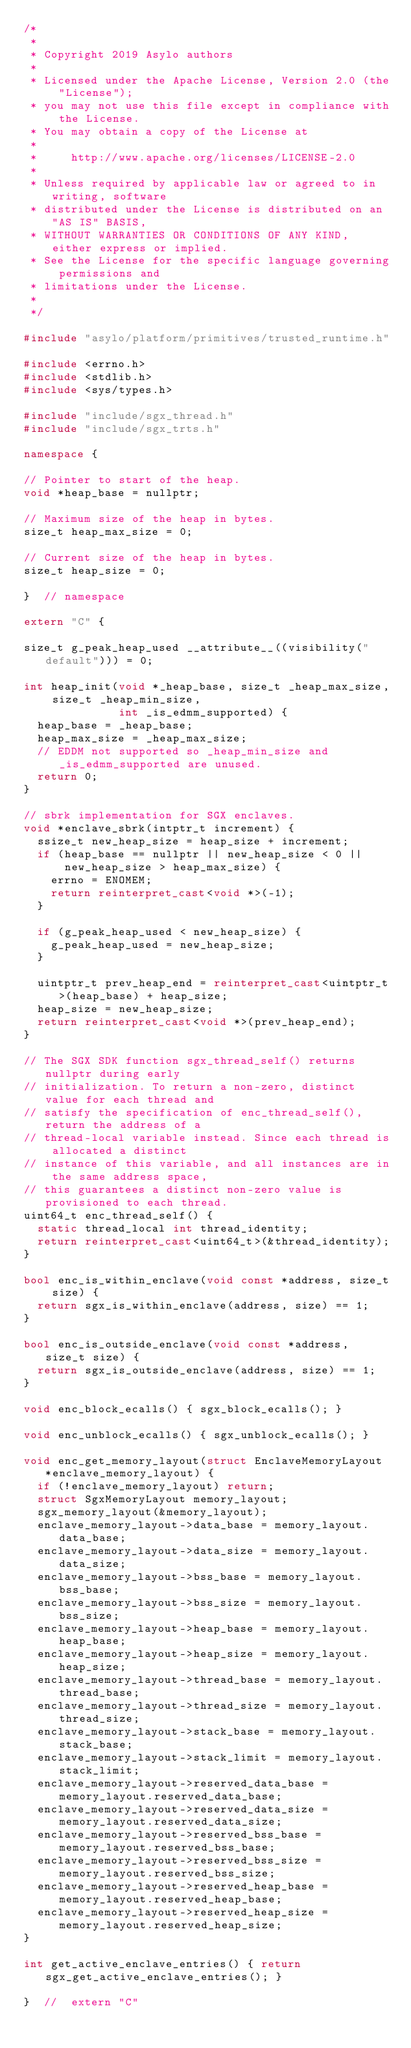Convert code to text. <code><loc_0><loc_0><loc_500><loc_500><_C++_>/*
 *
 * Copyright 2019 Asylo authors
 *
 * Licensed under the Apache License, Version 2.0 (the "License");
 * you may not use this file except in compliance with the License.
 * You may obtain a copy of the License at
 *
 *     http://www.apache.org/licenses/LICENSE-2.0
 *
 * Unless required by applicable law or agreed to in writing, software
 * distributed under the License is distributed on an "AS IS" BASIS,
 * WITHOUT WARRANTIES OR CONDITIONS OF ANY KIND, either express or implied.
 * See the License for the specific language governing permissions and
 * limitations under the License.
 *
 */

#include "asylo/platform/primitives/trusted_runtime.h"

#include <errno.h>
#include <stdlib.h>
#include <sys/types.h>

#include "include/sgx_thread.h"
#include "include/sgx_trts.h"

namespace {

// Pointer to start of the heap.
void *heap_base = nullptr;

// Maximum size of the heap in bytes.
size_t heap_max_size = 0;

// Current size of the heap in bytes.
size_t heap_size = 0;

}  // namespace

extern "C" {

size_t g_peak_heap_used __attribute__((visibility("default"))) = 0;

int heap_init(void *_heap_base, size_t _heap_max_size, size_t _heap_min_size,
              int _is_edmm_supported) {
  heap_base = _heap_base;
  heap_max_size = _heap_max_size;
  // EDDM not supported so _heap_min_size and _is_edmm_supported are unused.
  return 0;
}

// sbrk implementation for SGX enclaves.
void *enclave_sbrk(intptr_t increment) {
  ssize_t new_heap_size = heap_size + increment;
  if (heap_base == nullptr || new_heap_size < 0 ||
      new_heap_size > heap_max_size) {
    errno = ENOMEM;
    return reinterpret_cast<void *>(-1);
  }

  if (g_peak_heap_used < new_heap_size) {
    g_peak_heap_used = new_heap_size;
  }

  uintptr_t prev_heap_end = reinterpret_cast<uintptr_t>(heap_base) + heap_size;
  heap_size = new_heap_size;
  return reinterpret_cast<void *>(prev_heap_end);
}

// The SGX SDK function sgx_thread_self() returns nullptr during early
// initialization. To return a non-zero, distinct value for each thread and
// satisfy the specification of enc_thread_self(), return the address of a
// thread-local variable instead. Since each thread is allocated a distinct
// instance of this variable, and all instances are in the same address space,
// this guarantees a distinct non-zero value is provisioned to each thread.
uint64_t enc_thread_self() {
  static thread_local int thread_identity;
  return reinterpret_cast<uint64_t>(&thread_identity);
}

bool enc_is_within_enclave(void const *address, size_t size) {
  return sgx_is_within_enclave(address, size) == 1;
}

bool enc_is_outside_enclave(void const *address, size_t size) {
  return sgx_is_outside_enclave(address, size) == 1;
}

void enc_block_ecalls() { sgx_block_ecalls(); }

void enc_unblock_ecalls() { sgx_unblock_ecalls(); }

void enc_get_memory_layout(struct EnclaveMemoryLayout *enclave_memory_layout) {
  if (!enclave_memory_layout) return;
  struct SgxMemoryLayout memory_layout;
  sgx_memory_layout(&memory_layout);
  enclave_memory_layout->data_base = memory_layout.data_base;
  enclave_memory_layout->data_size = memory_layout.data_size;
  enclave_memory_layout->bss_base = memory_layout.bss_base;
  enclave_memory_layout->bss_size = memory_layout.bss_size;
  enclave_memory_layout->heap_base = memory_layout.heap_base;
  enclave_memory_layout->heap_size = memory_layout.heap_size;
  enclave_memory_layout->thread_base = memory_layout.thread_base;
  enclave_memory_layout->thread_size = memory_layout.thread_size;
  enclave_memory_layout->stack_base = memory_layout.stack_base;
  enclave_memory_layout->stack_limit = memory_layout.stack_limit;
  enclave_memory_layout->reserved_data_base = memory_layout.reserved_data_base;
  enclave_memory_layout->reserved_data_size = memory_layout.reserved_data_size;
  enclave_memory_layout->reserved_bss_base = memory_layout.reserved_bss_base;
  enclave_memory_layout->reserved_bss_size = memory_layout.reserved_bss_size;
  enclave_memory_layout->reserved_heap_base = memory_layout.reserved_heap_base;
  enclave_memory_layout->reserved_heap_size = memory_layout.reserved_heap_size;
}

int get_active_enclave_entries() { return sgx_get_active_enclave_entries(); }

}  //  extern "C"
</code> 